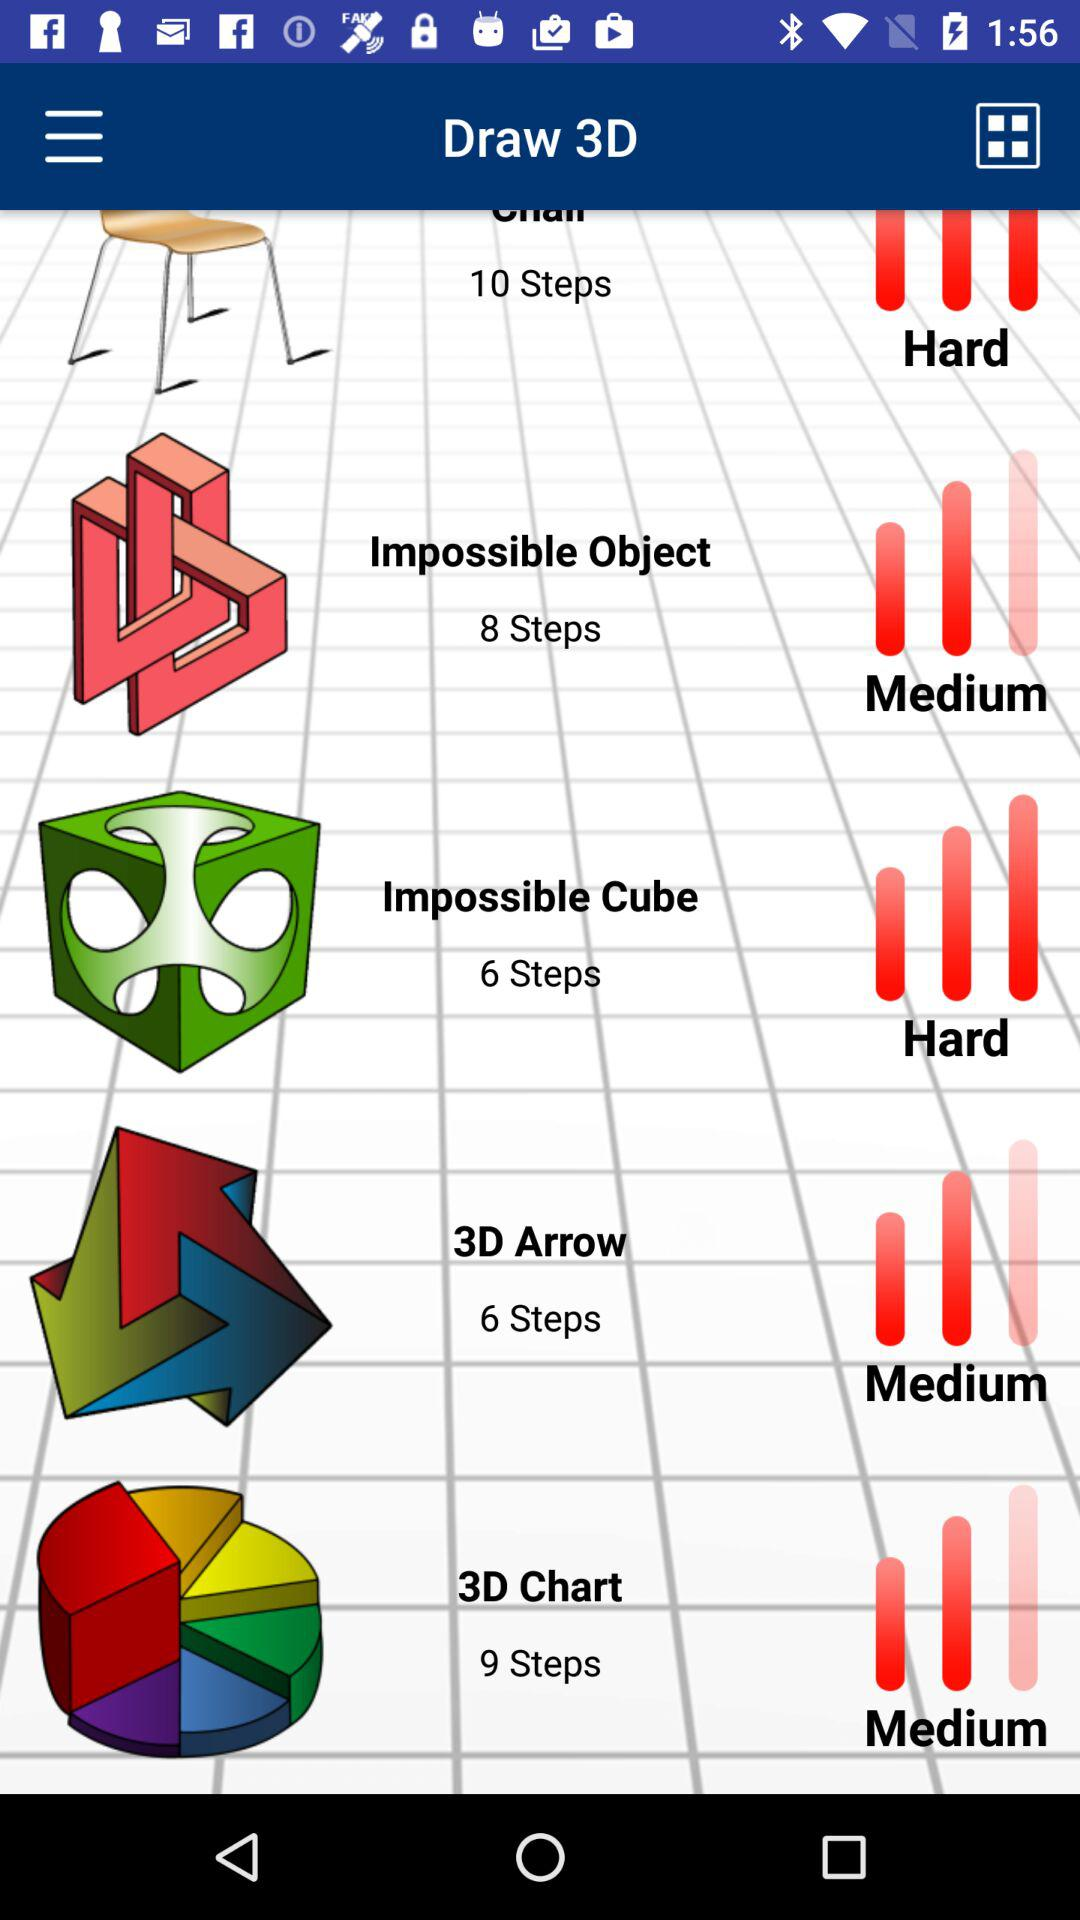How many steps are there for the "3D Chart"? There are 9 steps for the "3D Chart". 